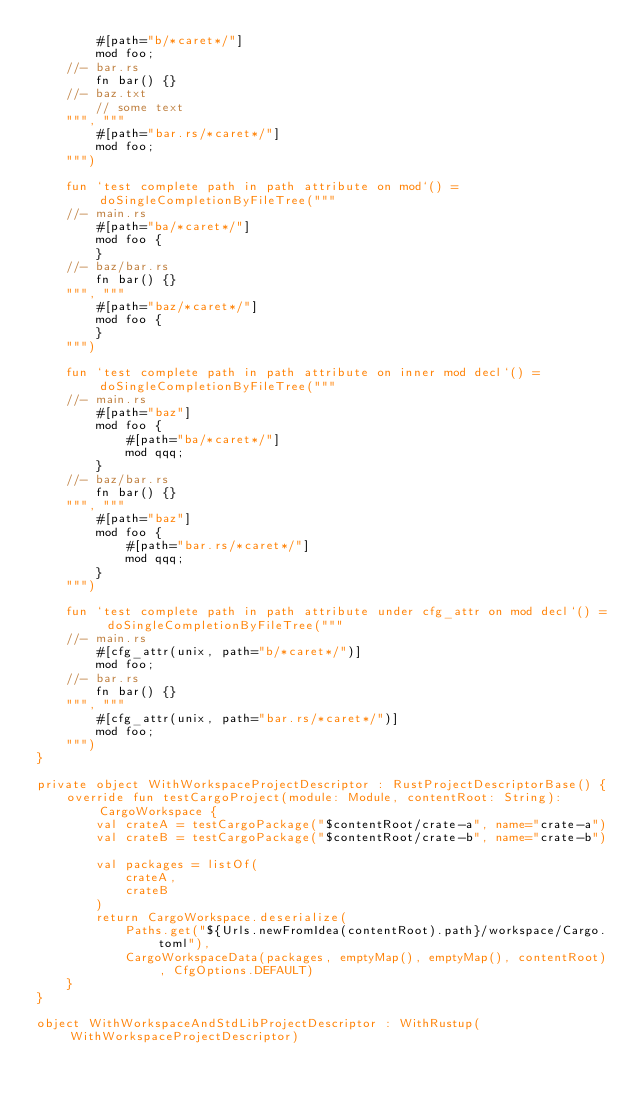<code> <loc_0><loc_0><loc_500><loc_500><_Kotlin_>        #[path="b/*caret*/"]
        mod foo;
    //- bar.rs
        fn bar() {}
    //- baz.txt
        // some text
    """, """
        #[path="bar.rs/*caret*/"]
        mod foo;
    """)

    fun `test complete path in path attribute on mod`() = doSingleCompletionByFileTree("""
    //- main.rs
        #[path="ba/*caret*/"]
        mod foo {
        }
    //- baz/bar.rs
        fn bar() {}
    """, """
        #[path="baz/*caret*/"]
        mod foo {
        }
    """)

    fun `test complete path in path attribute on inner mod decl`() = doSingleCompletionByFileTree("""
    //- main.rs
        #[path="baz"]
        mod foo {
            #[path="ba/*caret*/"]
            mod qqq;
        }
    //- baz/bar.rs
        fn bar() {}
    """, """
        #[path="baz"]
        mod foo {
            #[path="bar.rs/*caret*/"]
            mod qqq;
        }
    """)

    fun `test complete path in path attribute under cfg_attr on mod decl`() = doSingleCompletionByFileTree("""
    //- main.rs
        #[cfg_attr(unix, path="b/*caret*/")]
        mod foo;
    //- bar.rs
        fn bar() {}
    """, """
        #[cfg_attr(unix, path="bar.rs/*caret*/")]
        mod foo;
    """)
}

private object WithWorkspaceProjectDescriptor : RustProjectDescriptorBase() {
    override fun testCargoProject(module: Module, contentRoot: String): CargoWorkspace {
        val crateA = testCargoPackage("$contentRoot/crate-a", name="crate-a")
        val crateB = testCargoPackage("$contentRoot/crate-b", name="crate-b")

        val packages = listOf(
            crateA,
            crateB
        )
        return CargoWorkspace.deserialize(
            Paths.get("${Urls.newFromIdea(contentRoot).path}/workspace/Cargo.toml"),
            CargoWorkspaceData(packages, emptyMap(), emptyMap(), contentRoot), CfgOptions.DEFAULT)
    }
}

object WithWorkspaceAndStdLibProjectDescriptor : WithRustup(WithWorkspaceProjectDescriptor)
</code> 